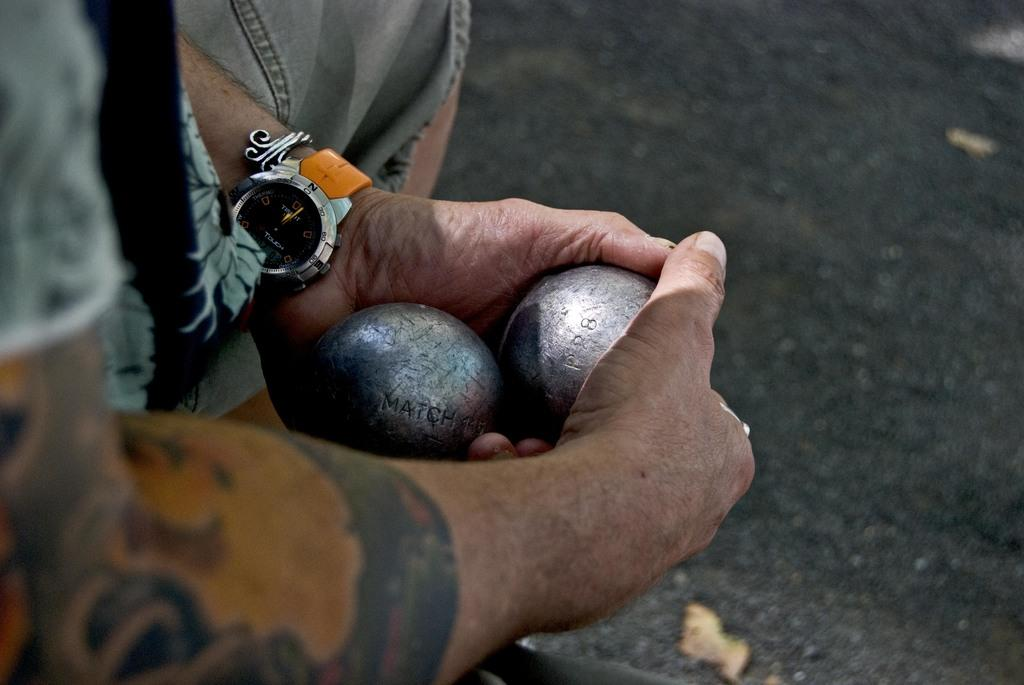<image>
Write a terse but informative summary of the picture. A man holds a metal ball with the imprint P28 on it. 